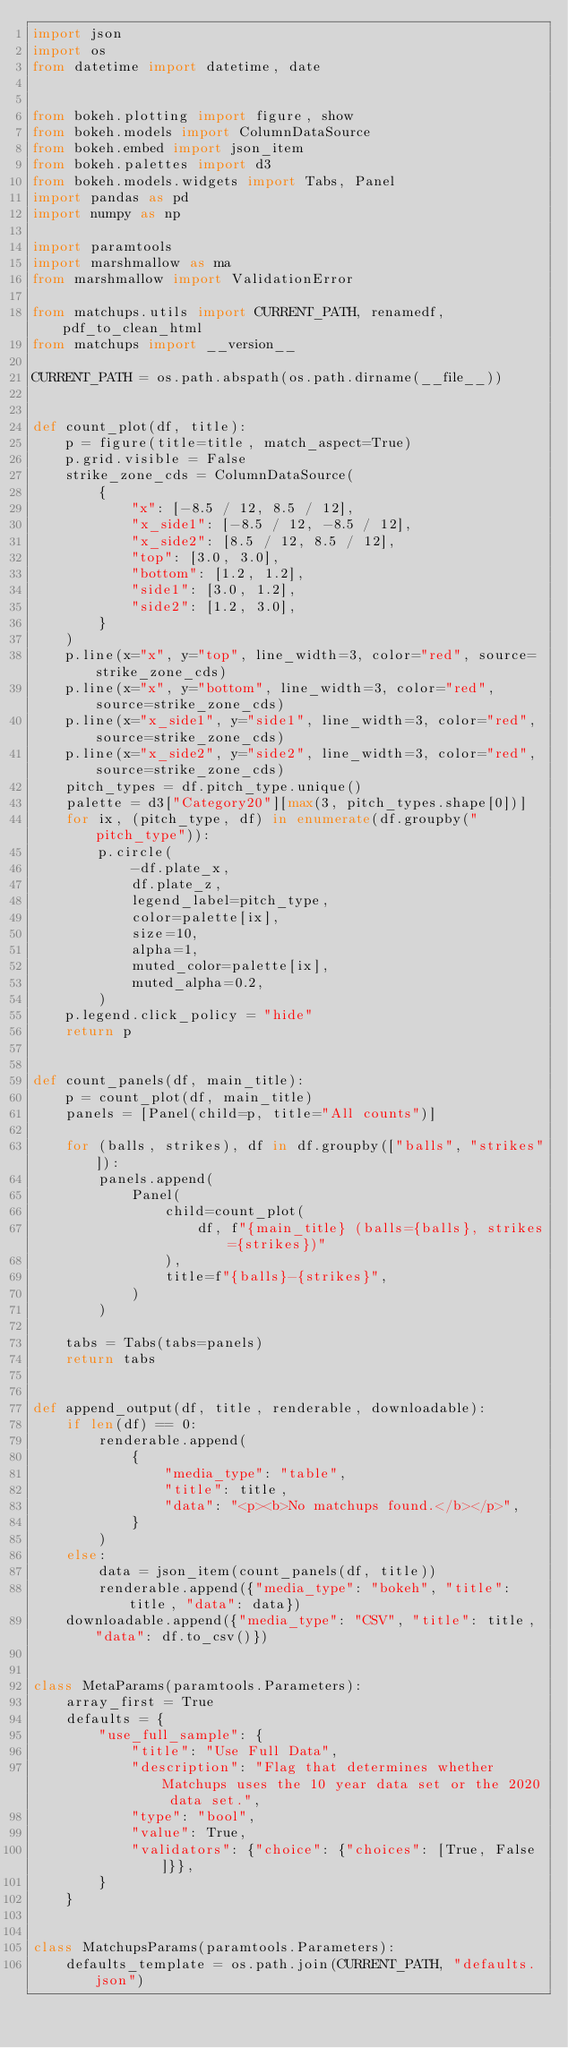Convert code to text. <code><loc_0><loc_0><loc_500><loc_500><_Python_>import json
import os
from datetime import datetime, date


from bokeh.plotting import figure, show
from bokeh.models import ColumnDataSource
from bokeh.embed import json_item
from bokeh.palettes import d3
from bokeh.models.widgets import Tabs, Panel
import pandas as pd
import numpy as np

import paramtools
import marshmallow as ma
from marshmallow import ValidationError

from matchups.utils import CURRENT_PATH, renamedf, pdf_to_clean_html
from matchups import __version__

CURRENT_PATH = os.path.abspath(os.path.dirname(__file__))


def count_plot(df, title):
    p = figure(title=title, match_aspect=True)
    p.grid.visible = False
    strike_zone_cds = ColumnDataSource(
        {
            "x": [-8.5 / 12, 8.5 / 12],
            "x_side1": [-8.5 / 12, -8.5 / 12],
            "x_side2": [8.5 / 12, 8.5 / 12],
            "top": [3.0, 3.0],
            "bottom": [1.2, 1.2],
            "side1": [3.0, 1.2],
            "side2": [1.2, 3.0],
        }
    )
    p.line(x="x", y="top", line_width=3, color="red", source=strike_zone_cds)
    p.line(x="x", y="bottom", line_width=3, color="red", source=strike_zone_cds)
    p.line(x="x_side1", y="side1", line_width=3, color="red", source=strike_zone_cds)
    p.line(x="x_side2", y="side2", line_width=3, color="red", source=strike_zone_cds)
    pitch_types = df.pitch_type.unique()
    palette = d3["Category20"][max(3, pitch_types.shape[0])]
    for ix, (pitch_type, df) in enumerate(df.groupby("pitch_type")):
        p.circle(
            -df.plate_x,
            df.plate_z,
            legend_label=pitch_type,
            color=palette[ix],
            size=10,
            alpha=1,
            muted_color=palette[ix],
            muted_alpha=0.2,
        )
    p.legend.click_policy = "hide"
    return p


def count_panels(df, main_title):
    p = count_plot(df, main_title)
    panels = [Panel(child=p, title="All counts")]

    for (balls, strikes), df in df.groupby(["balls", "strikes"]):
        panels.append(
            Panel(
                child=count_plot(
                    df, f"{main_title} (balls={balls}, strikes={strikes})"
                ),
                title=f"{balls}-{strikes}",
            )
        )

    tabs = Tabs(tabs=panels)
    return tabs


def append_output(df, title, renderable, downloadable):
    if len(df) == 0:
        renderable.append(
            {
                "media_type": "table",
                "title": title,
                "data": "<p><b>No matchups found.</b></p>",
            }
        )
    else:
        data = json_item(count_panels(df, title))
        renderable.append({"media_type": "bokeh", "title": title, "data": data})
    downloadable.append({"media_type": "CSV", "title": title, "data": df.to_csv()})


class MetaParams(paramtools.Parameters):
    array_first = True
    defaults = {
        "use_full_sample": {
            "title": "Use Full Data",
            "description": "Flag that determines whether Matchups uses the 10 year data set or the 2020 data set.",
            "type": "bool",
            "value": True,
            "validators": {"choice": {"choices": [True, False]}},
        }
    }


class MatchupsParams(paramtools.Parameters):
    defaults_template = os.path.join(CURRENT_PATH, "defaults.json")
</code> 